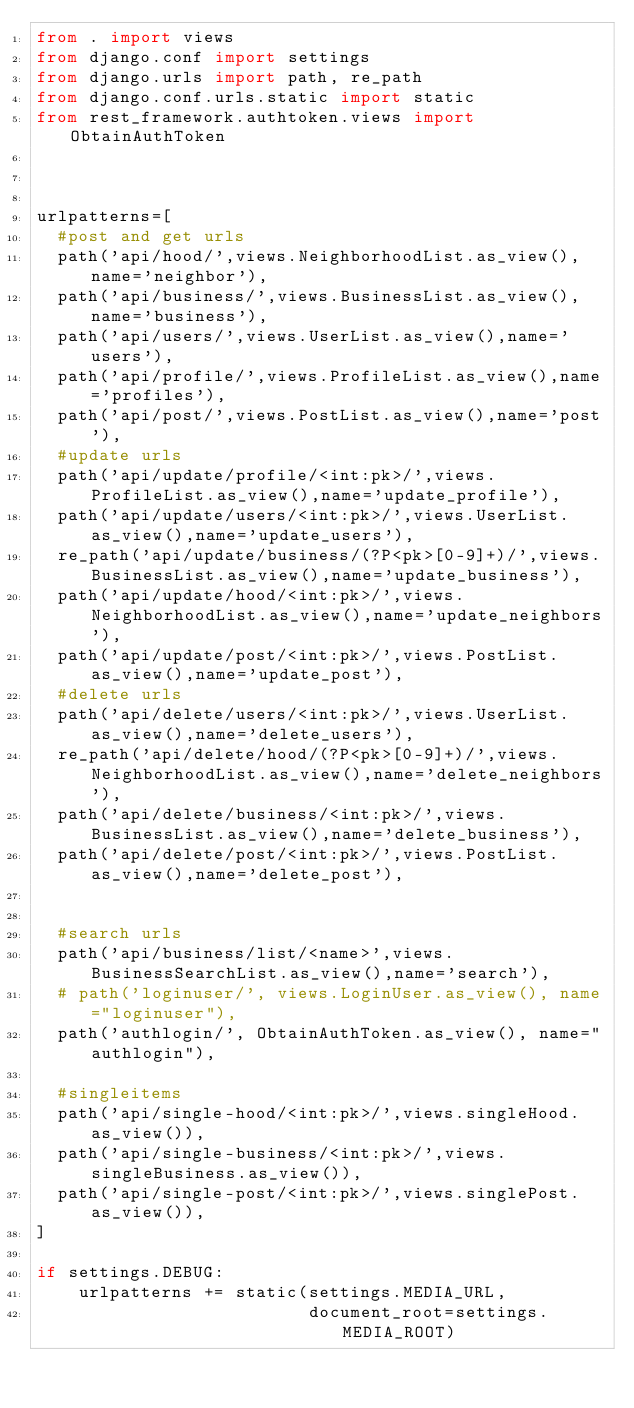<code> <loc_0><loc_0><loc_500><loc_500><_Python_>from . import views
from django.conf import settings
from django.urls import path, re_path
from django.conf.urls.static import static
from rest_framework.authtoken.views import ObtainAuthToken



urlpatterns=[
  #post and get urls
  path('api/hood/',views.NeighborhoodList.as_view(),name='neighbor'),
  path('api/business/',views.BusinessList.as_view(),name='business'),
  path('api/users/',views.UserList.as_view(),name='users'),
  path('api/profile/',views.ProfileList.as_view(),name='profiles'),
  path('api/post/',views.PostList.as_view(),name='post'),
  #update urls
  path('api/update/profile/<int:pk>/',views.ProfileList.as_view(),name='update_profile'),
  path('api/update/users/<int:pk>/',views.UserList.as_view(),name='update_users'),
  re_path('api/update/business/(?P<pk>[0-9]+)/',views.BusinessList.as_view(),name='update_business'),
  path('api/update/hood/<int:pk>/',views.NeighborhoodList.as_view(),name='update_neighbors'),
  path('api/update/post/<int:pk>/',views.PostList.as_view(),name='update_post'),
  #delete urls
  path('api/delete/users/<int:pk>/',views.UserList.as_view(),name='delete_users'),
  re_path('api/delete/hood/(?P<pk>[0-9]+)/',views.NeighborhoodList.as_view(),name='delete_neighbors'),
  path('api/delete/business/<int:pk>/',views.BusinessList.as_view(),name='delete_business'),
  path('api/delete/post/<int:pk>/',views.PostList.as_view(),name='delete_post'),


  #search urls
  path('api/business/list/<name>',views.BusinessSearchList.as_view(),name='search'),
  # path('loginuser/', views.LoginUser.as_view(), name="loginuser"),
  path('authlogin/', ObtainAuthToken.as_view(), name="authlogin"),

  #singleitems
  path('api/single-hood/<int:pk>/',views.singleHood.as_view()),
  path('api/single-business/<int:pk>/',views.singleBusiness.as_view()),
  path('api/single-post/<int:pk>/',views.singlePost.as_view()),
]

if settings.DEBUG:
    urlpatterns += static(settings.MEDIA_URL,
                          document_root=settings.MEDIA_ROOT)</code> 